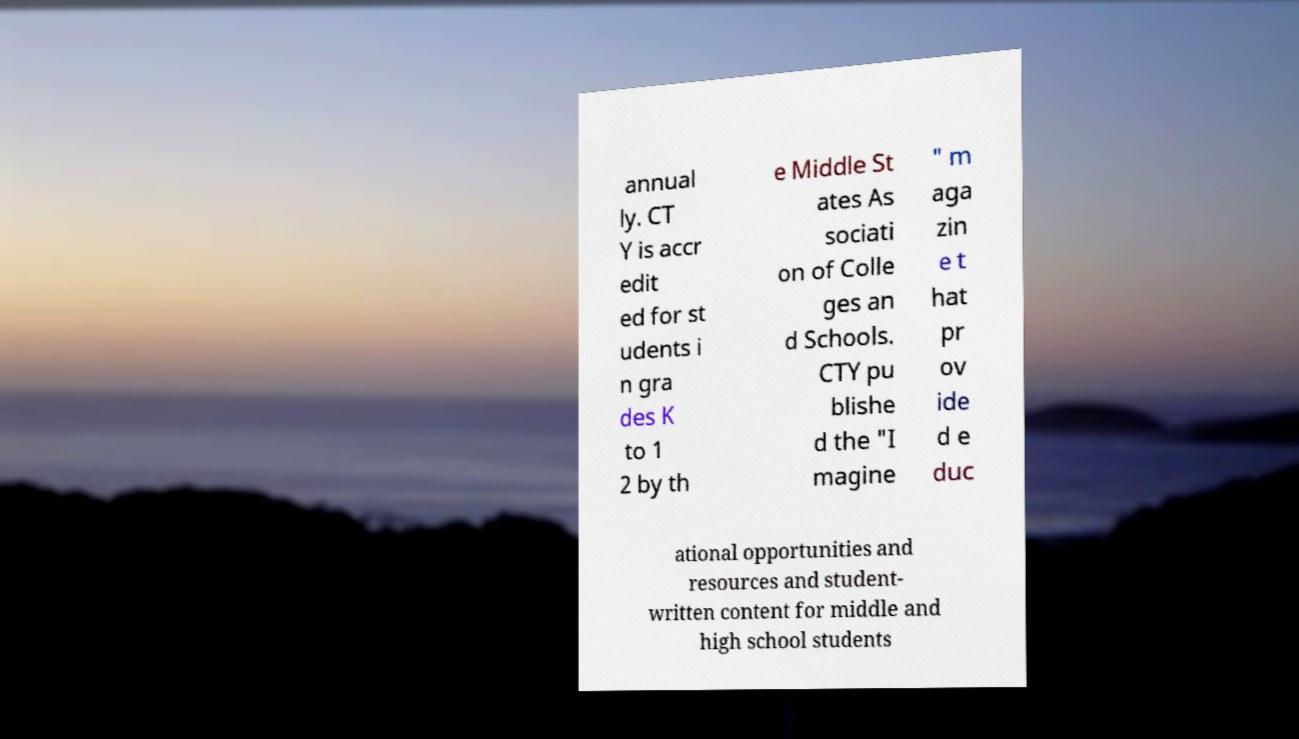For documentation purposes, I need the text within this image transcribed. Could you provide that? annual ly. CT Y is accr edit ed for st udents i n gra des K to 1 2 by th e Middle St ates As sociati on of Colle ges an d Schools. CTY pu blishe d the "I magine " m aga zin e t hat pr ov ide d e duc ational opportunities and resources and student- written content for middle and high school students 